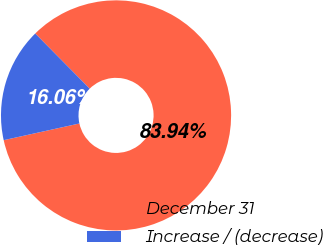Convert chart. <chart><loc_0><loc_0><loc_500><loc_500><pie_chart><fcel>December 31<fcel>Increase / (decrease)<nl><fcel>83.94%<fcel>16.06%<nl></chart> 